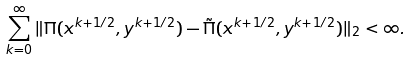Convert formula to latex. <formula><loc_0><loc_0><loc_500><loc_500>\sum _ { k = 0 } ^ { \infty } \| \Pi ( x ^ { k + 1 / 2 } , y ^ { k + 1 / 2 } ) - \tilde { \Pi } ( x ^ { k + 1 / 2 } , y ^ { k + 1 / 2 } ) \| _ { 2 } < \infty .</formula> 